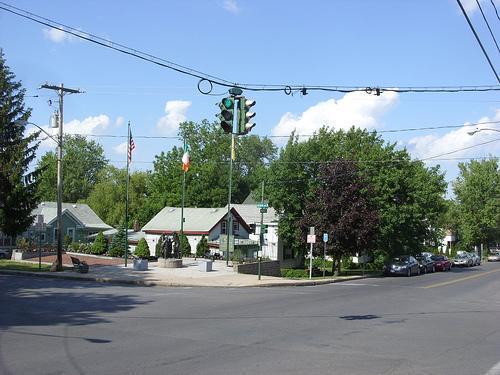How many traffic lights are in the photo?
Give a very brief answer. 1. How many american flags are visible?
Give a very brief answer. 1. How many houses are visible?
Give a very brief answer. 3. 